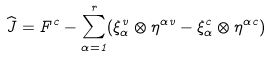Convert formula to latex. <formula><loc_0><loc_0><loc_500><loc_500>\widehat { J } = { F } ^ { c } - \sum _ { \alpha = 1 } ^ { r } ( \xi _ { \alpha } ^ { v } \otimes \eta ^ { \alpha v } - \xi _ { \alpha } ^ { c } \otimes \eta ^ { \alpha c } )</formula> 